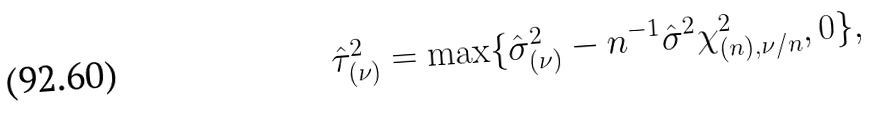<formula> <loc_0><loc_0><loc_500><loc_500>\hat { \tau } _ { ( \nu ) } ^ { 2 } = \max \{ \hat { \sigma } _ { ( \nu ) } ^ { 2 } - n ^ { - 1 } \hat { \sigma } ^ { 2 } \chi _ { ( n ) , \nu / n } ^ { 2 } , 0 \} ,</formula> 